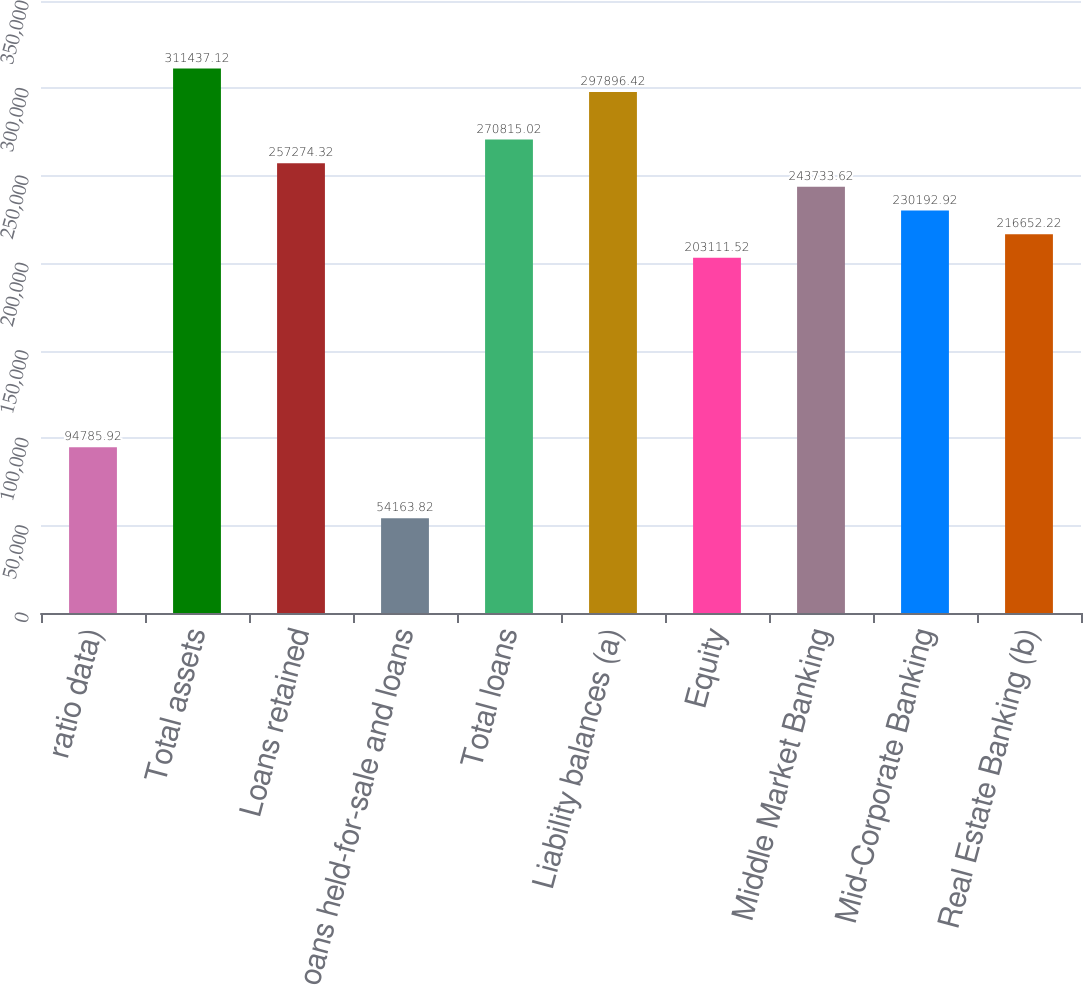Convert chart to OTSL. <chart><loc_0><loc_0><loc_500><loc_500><bar_chart><fcel>ratio data)<fcel>Total assets<fcel>Loans retained<fcel>Loans held-for-sale and loans<fcel>Total loans<fcel>Liability balances (a)<fcel>Equity<fcel>Middle Market Banking<fcel>Mid-Corporate Banking<fcel>Real Estate Banking (b)<nl><fcel>94785.9<fcel>311437<fcel>257274<fcel>54163.8<fcel>270815<fcel>297896<fcel>203112<fcel>243734<fcel>230193<fcel>216652<nl></chart> 